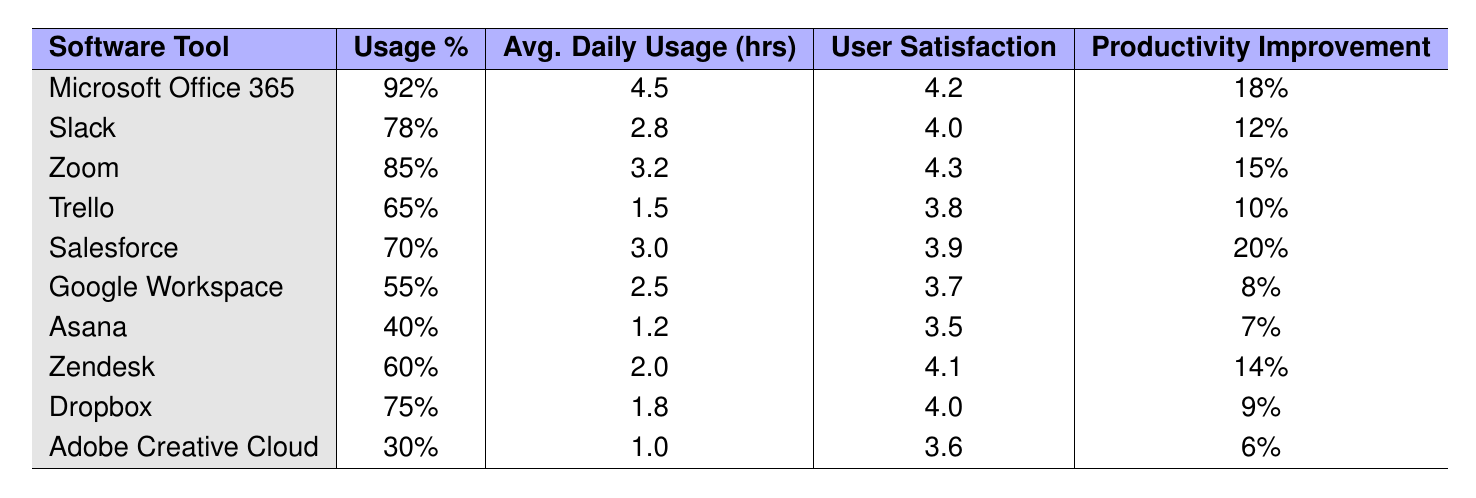What is the software tool with the highest usage percentage? By examining the 'Usage Percentage' column in the table, it is clear that 'Microsoft Office 365' has the highest percentage at 92%.
Answer: Microsoft Office 365 Which software tool has the lowest user satisfaction rating? The 'User Satisfaction Rating' column indicates that 'Asana' has the lowest rating, which is 3.5.
Answer: Asana What is the average daily usage in hours for Slack? The table shows that the average daily usage for Slack is 2.8 hours.
Answer: 2.8 hours Is the productivity improvement for Zoom greater than for Trello? Comparing the 'Productivity Improvement' values, Zoom has a 15% improvement while Trello has 10%, so it is true that Zoom's improvement is greater.
Answer: Yes What is the average user satisfaction rating for all software tools listed? Calculating the average involves summing the satisfaction ratings and dividing by the number of tools. (4.2 + 4.0 + 4.3 + 3.8 + 3.9 + 3.7 + 3.5 + 4.1 + 4.0 + 3.6) = 39.1, and then dividing by 10 gives 3.91.
Answer: 3.91 Which software tools have productivity improvements greater than 10%? Looking at the 'Productivity Improvement' column, the tools with improvements greater than 10% are Microsoft Office 365 (18%), Salesforce (20%), Zoom (15%), and Zendesk (14%).
Answer: Microsoft Office 365, Salesforce, Zoom, Zendesk Calculate the total average daily usage (in hours) for all tools listed. Summing up the average daily usage hours: 4.5 + 2.8 + 3.2 + 1.5 + 3.0 + 2.5 + 1.2 + 2.0 + 1.8 + 1.0 = 24.5. There are 10 tools, so the average is 24.5 / 10 = 2.45 hours.
Answer: 2.45 hours Does Google Workspace have a higher usage percentage than Adobe Creative Cloud? Comparing the usage percentages, Google Workspace has 55% while Adobe Creative Cloud has 30%. The percentage for Google Workspace is indeed higher.
Answer: Yes How many software tools have a user satisfaction rating above 4.0? Checking the ratings, the tools with ratings above 4.0 are Microsoft Office 365 (4.2), Zoom (4.3), Zendesk (4.1), and Slack (4.0). Therefore, 4 tools fit this criterion.
Answer: 4 tools Which software tool has the largest difference between usage percentage and user satisfaction rating? Calculating the difference for each: Microsoft Office 365 (92% - 4.2), Slack (78% - 4.0), Zoom (85% - 4.3), Trello (65% - 3.8), Salesforce (70% - 3.9), Google Workspace (55% - 3.7), Asana (40% - 3.5), Zendesk (60% - 4.1), Dropbox (75% - 4.0), Adobe Creative Cloud (30% - 3.6). The largest difference is 92% - 4.2, equating to 87.8%.
Answer: Microsoft Office 365 